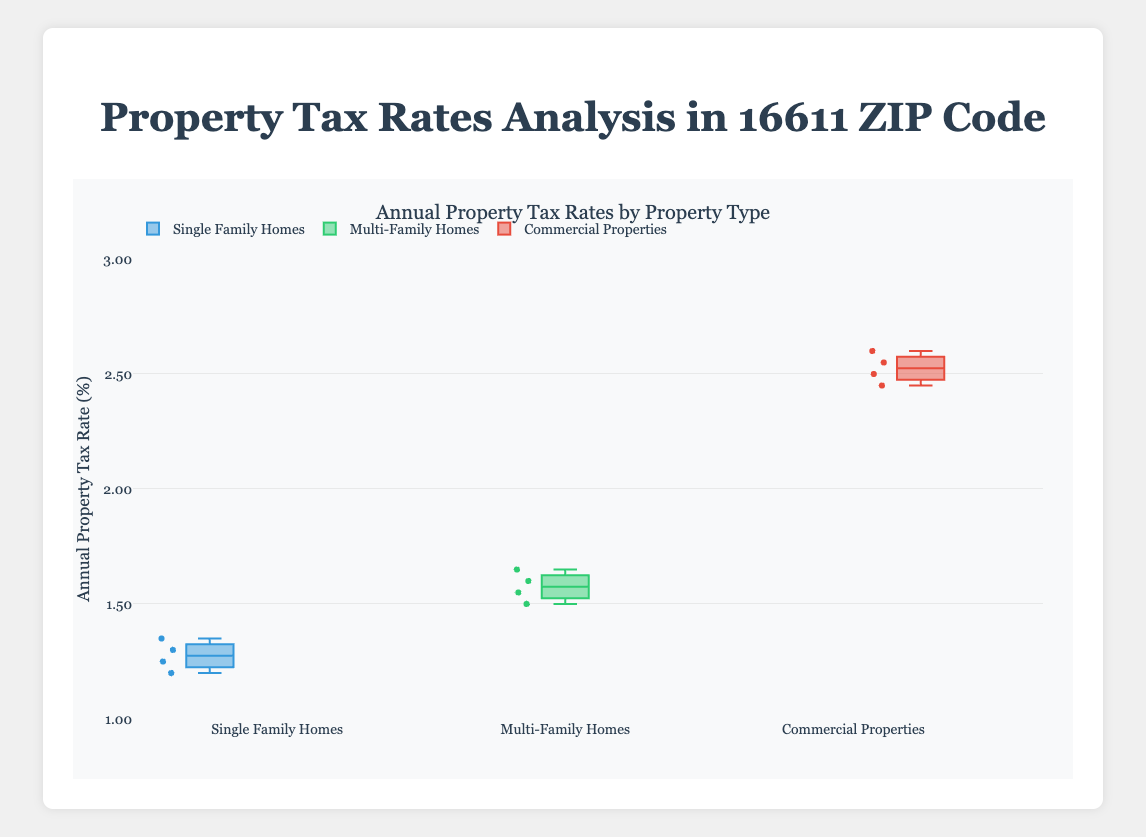What is the overall range of annual property tax rates for single-family homes? The range can be determined by finding the difference between the highest and lowest tax rates among single-family homes. The highest rate is 1.35% and the lowest is 1.20%. The range is 1.35 - 1.20.
Answer: 0.15% What is the median annual property tax rate for multi-family homes? The median is found by sorting the rates and identifying the middle value. For multi-family homes, the rates are 1.50, 1.55, 1.60, and 1.65. The median is the average of the two middle values: (1.55 + 1.60) / 2 = 1.575.
Answer: 1.575% Which property type has the highest median annual property tax rate? To identify the property type with the highest median, compare the medians: single-family homes (1.275%), multi-family homes (1.575%), commercial properties (2.525%).
Answer: Commercial properties What is the interquartile range (IQR) for the annual property tax rates of commercial properties? The IQR is the difference between the third quartile (Q3) and the first quartile (Q1). For commercial properties, the rates are 2.45%, 2.50%, 2.55%, and 2.60%. Q1 is 2.475% and Q3 is 2.575%. IQR = 2.575 - 2.475.
Answer: 0.10% How does the variability in tax rates for single-family homes compare to that for commercial properties? Variability can be assessed by the spread shown in the box plots. Single-family homes have a tighter range (1.20% to 1.35%) compared to commercial properties (2.45% to 2.60%). Alternatively, check the lengths of the boxes and whiskers.
Answer: Single-family homes have lower variability Which property type has the widest range of annual property tax rates? The range is computed as the difference between the maximum and minimum values for each property type. Single-family homes range is 0.15%, multi-family homes is 0.15%, and commercial properties is 0.15%. While they technically have the same numerical range, check the actual values to ensure accuracy.
Answer: Commercial properties Between which two property types is the difference between their median tax rates the greatest? Compare the differences between medians of the property types: single-family homes (1.275%), multi-family homes (1.575%), commercial properties (2.525%). The largest difference is between commercial properties and single-family homes (2.525 - 1.275).
Answer: Commercial properties and single-family homes Is there any overlap in the annual property tax rates for all three property types? Overlap is observed if any rates are common across all properties. Single-family homes (1.20%–1.35%), multi-family homes (1.50%–1.65%), commercial properties (2.45%–2.60%). No rates fall within the same range across all three.
Answer: No 